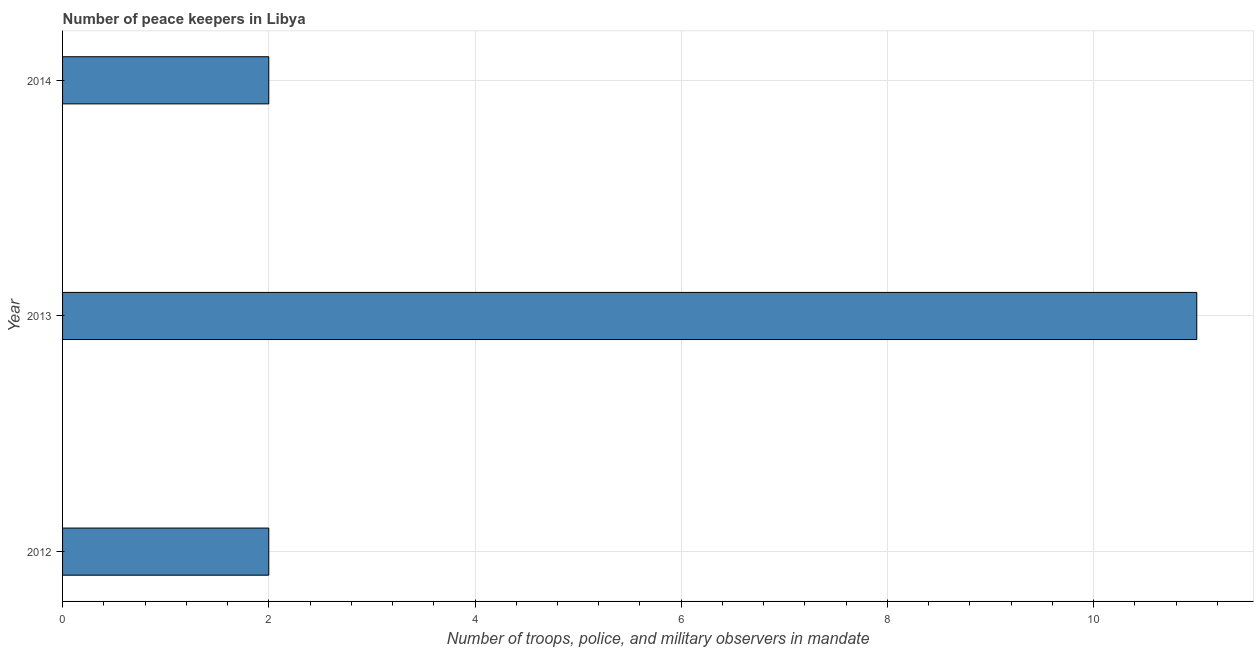Does the graph contain grids?
Offer a terse response. Yes. What is the title of the graph?
Provide a short and direct response. Number of peace keepers in Libya. What is the label or title of the X-axis?
Offer a terse response. Number of troops, police, and military observers in mandate. What is the label or title of the Y-axis?
Keep it short and to the point. Year. What is the number of peace keepers in 2013?
Offer a very short reply. 11. Across all years, what is the minimum number of peace keepers?
Provide a succinct answer. 2. In which year was the number of peace keepers minimum?
Keep it short and to the point. 2012. What is the difference between the number of peace keepers in 2012 and 2014?
Your answer should be compact. 0. What is the average number of peace keepers per year?
Your answer should be compact. 5. What is the median number of peace keepers?
Your answer should be very brief. 2. In how many years, is the number of peace keepers greater than 2.8 ?
Give a very brief answer. 1. Is the number of peace keepers in 2012 less than that in 2013?
Keep it short and to the point. Yes. Is the difference between the number of peace keepers in 2013 and 2014 greater than the difference between any two years?
Provide a short and direct response. Yes. What is the difference between the highest and the second highest number of peace keepers?
Give a very brief answer. 9. What is the difference between the highest and the lowest number of peace keepers?
Your response must be concise. 9. In how many years, is the number of peace keepers greater than the average number of peace keepers taken over all years?
Your answer should be very brief. 1. What is the difference between two consecutive major ticks on the X-axis?
Give a very brief answer. 2. Are the values on the major ticks of X-axis written in scientific E-notation?
Give a very brief answer. No. What is the Number of troops, police, and military observers in mandate of 2014?
Provide a short and direct response. 2. What is the difference between the Number of troops, police, and military observers in mandate in 2012 and 2013?
Your answer should be very brief. -9. What is the difference between the Number of troops, police, and military observers in mandate in 2012 and 2014?
Your answer should be compact. 0. What is the difference between the Number of troops, police, and military observers in mandate in 2013 and 2014?
Your response must be concise. 9. What is the ratio of the Number of troops, police, and military observers in mandate in 2012 to that in 2013?
Your answer should be very brief. 0.18. What is the ratio of the Number of troops, police, and military observers in mandate in 2012 to that in 2014?
Offer a terse response. 1. What is the ratio of the Number of troops, police, and military observers in mandate in 2013 to that in 2014?
Provide a succinct answer. 5.5. 